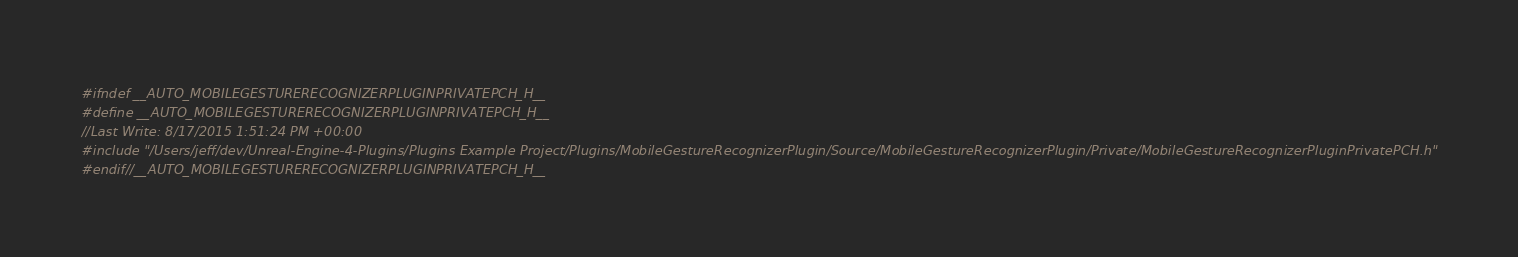<code> <loc_0><loc_0><loc_500><loc_500><_C_>#ifndef __AUTO_MOBILEGESTURERECOGNIZERPLUGINPRIVATEPCH_H__
#define __AUTO_MOBILEGESTURERECOGNIZERPLUGINPRIVATEPCH_H__
//Last Write: 8/17/2015 1:51:24 PM +00:00
#include "/Users/jeff/dev/Unreal-Engine-4-Plugins/Plugins Example Project/Plugins/MobileGestureRecognizerPlugin/Source/MobileGestureRecognizerPlugin/Private/MobileGestureRecognizerPluginPrivatePCH.h"
#endif//__AUTO_MOBILEGESTURERECOGNIZERPLUGINPRIVATEPCH_H__</code> 